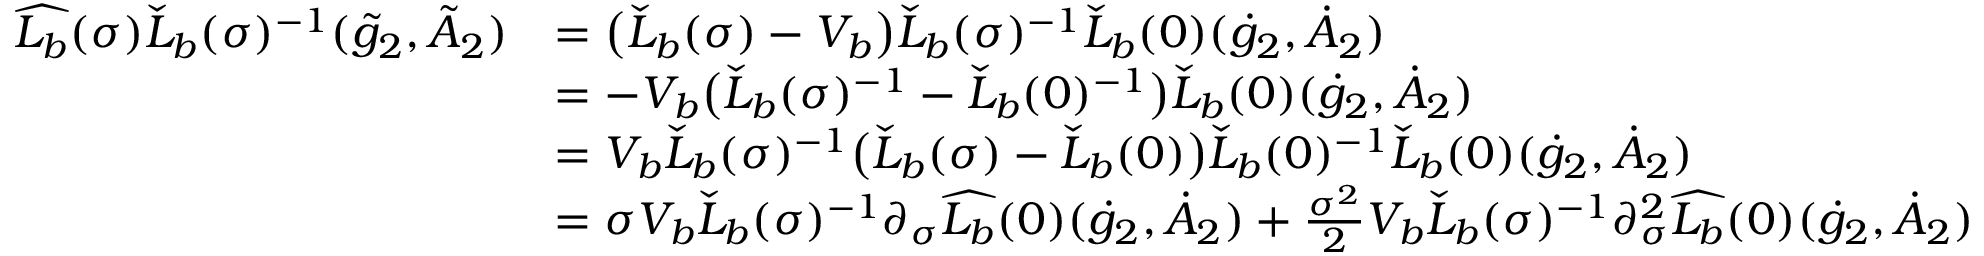<formula> <loc_0><loc_0><loc_500><loc_500>\begin{array} { r l } { \widehat { L _ { b } } ( \sigma ) \check { L } _ { b } ( \sigma ) ^ { - 1 } ( \tilde { g } _ { 2 } , \tilde { A } _ { 2 } ) } & { = \left ( \check { L } _ { b } ( \sigma ) - V _ { b } \right ) \check { L } _ { b } ( \sigma ) ^ { - 1 } \check { L } _ { b } ( 0 ) ( \dot { g } _ { 2 } , \dot { A } _ { 2 } ) } \\ & { = - V _ { b } \left ( \check { L } _ { b } ( \sigma ) ^ { - 1 } - \check { L } _ { b } ( 0 ) ^ { - 1 } \right ) \check { L } _ { b } ( 0 ) ( \dot { g } _ { 2 } , \dot { A } _ { 2 } ) } \\ & { = V _ { b } \check { L } _ { b } ( \sigma ) ^ { - 1 } \left ( \check { L } _ { b } ( \sigma ) - \check { L } _ { b } ( 0 ) \right ) \check { L } _ { b } ( 0 ) ^ { - 1 } \check { L } _ { b } ( 0 ) ( \dot { g } _ { 2 } , \dot { A } _ { 2 } ) } \\ & { = \sigma V _ { b } \check { L } _ { b } ( \sigma ) ^ { - 1 } \partial _ { \sigma } \widehat { L _ { b } } ( 0 ) ( \dot { g } _ { 2 } , \dot { A } _ { 2 } ) + \frac { \sigma ^ { 2 } } { 2 } V _ { b } \check { L } _ { b } ( \sigma ) ^ { - 1 } \partial _ { \sigma } ^ { 2 } \widehat { L _ { b } } ( 0 ) ( \dot { g } _ { 2 } , \dot { A } _ { 2 } ) } \end{array}</formula> 